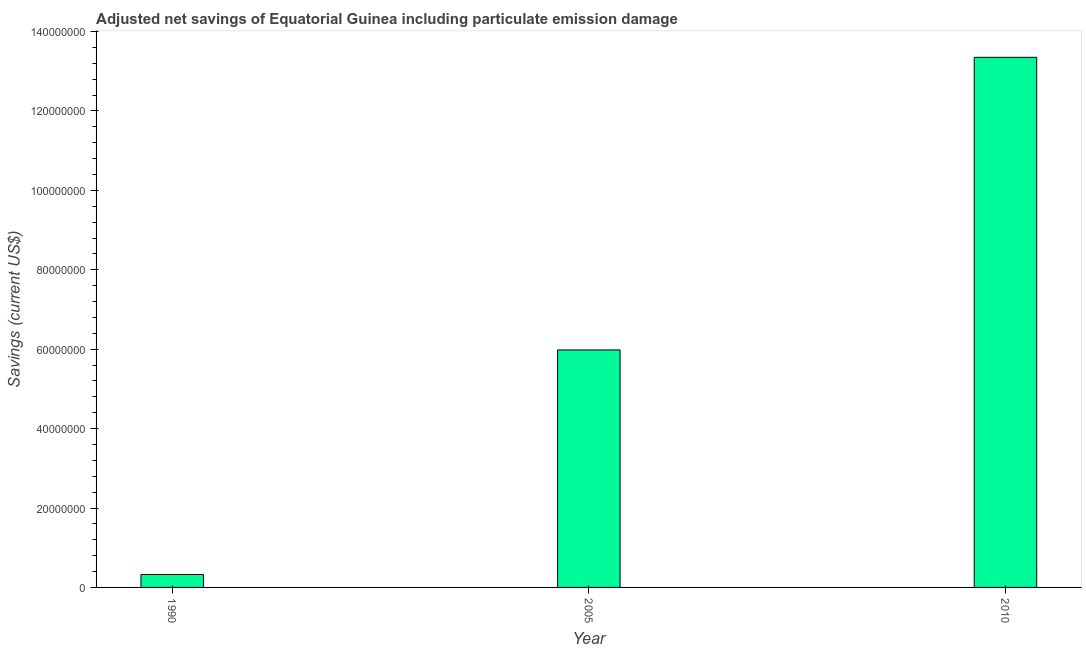Does the graph contain any zero values?
Ensure brevity in your answer.  No. What is the title of the graph?
Ensure brevity in your answer.  Adjusted net savings of Equatorial Guinea including particulate emission damage. What is the label or title of the Y-axis?
Make the answer very short. Savings (current US$). What is the adjusted net savings in 2005?
Offer a terse response. 5.98e+07. Across all years, what is the maximum adjusted net savings?
Provide a short and direct response. 1.34e+08. Across all years, what is the minimum adjusted net savings?
Your answer should be very brief. 3.26e+06. In which year was the adjusted net savings minimum?
Offer a very short reply. 1990. What is the sum of the adjusted net savings?
Provide a short and direct response. 1.97e+08. What is the difference between the adjusted net savings in 1990 and 2010?
Provide a succinct answer. -1.30e+08. What is the average adjusted net savings per year?
Make the answer very short. 6.55e+07. What is the median adjusted net savings?
Offer a terse response. 5.98e+07. In how many years, is the adjusted net savings greater than 28000000 US$?
Offer a terse response. 2. What is the ratio of the adjusted net savings in 2005 to that in 2010?
Offer a terse response. 0.45. Is the difference between the adjusted net savings in 1990 and 2010 greater than the difference between any two years?
Keep it short and to the point. Yes. What is the difference between the highest and the second highest adjusted net savings?
Your answer should be very brief. 7.37e+07. What is the difference between the highest and the lowest adjusted net savings?
Provide a short and direct response. 1.30e+08. What is the Savings (current US$) in 1990?
Provide a succinct answer. 3.26e+06. What is the Savings (current US$) of 2005?
Provide a succinct answer. 5.98e+07. What is the Savings (current US$) in 2010?
Provide a succinct answer. 1.34e+08. What is the difference between the Savings (current US$) in 1990 and 2005?
Ensure brevity in your answer.  -5.65e+07. What is the difference between the Savings (current US$) in 1990 and 2010?
Make the answer very short. -1.30e+08. What is the difference between the Savings (current US$) in 2005 and 2010?
Provide a short and direct response. -7.37e+07. What is the ratio of the Savings (current US$) in 1990 to that in 2005?
Give a very brief answer. 0.06. What is the ratio of the Savings (current US$) in 1990 to that in 2010?
Offer a terse response. 0.02. What is the ratio of the Savings (current US$) in 2005 to that in 2010?
Offer a terse response. 0.45. 